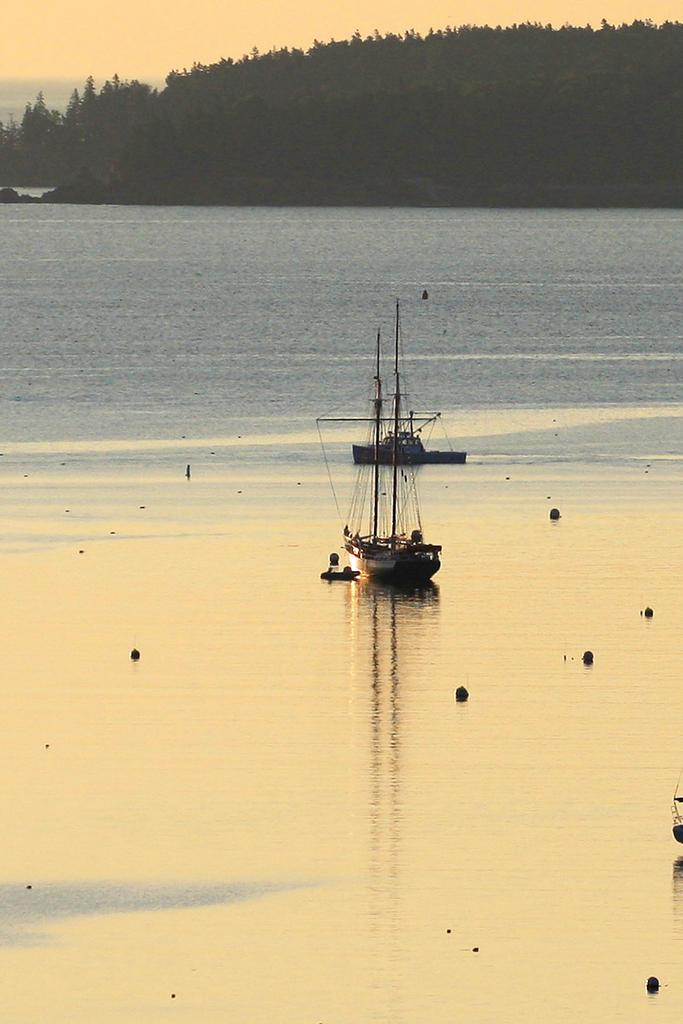What is in the water in the image? There are ships in the water. What can be seen in the background of the image? There are trees in the background. What is visible in the sky in the image? There are clouds in the sky. How many icicles are hanging from the trees in the image? There are no icicles present in the image, as it features ships in the water, trees in the background, and clouds in the sky. 